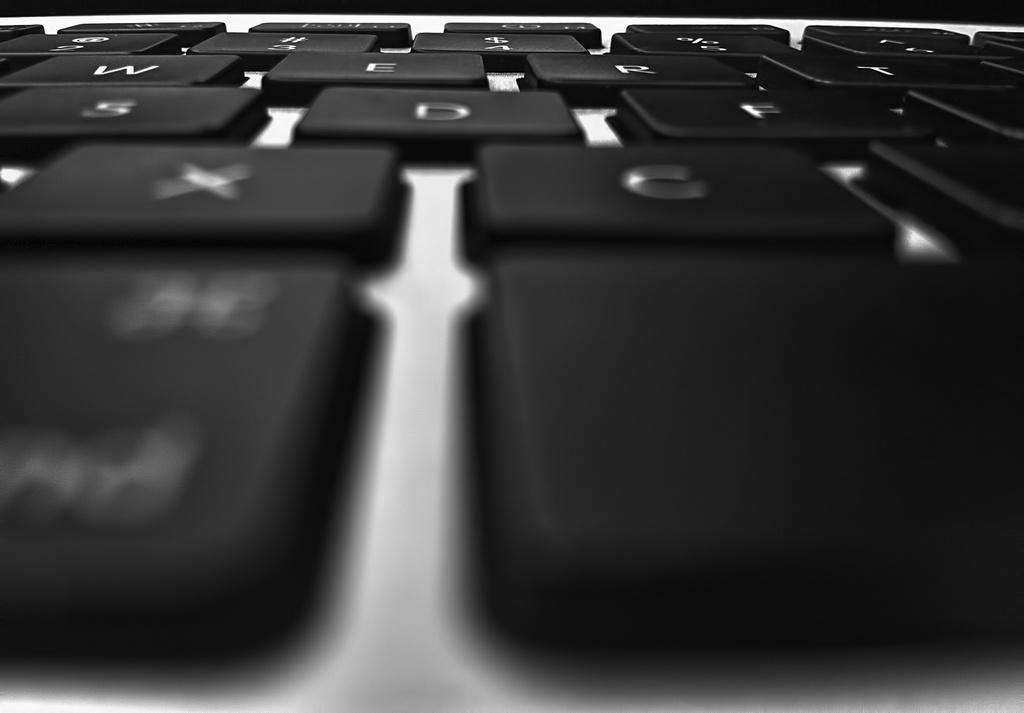Can you describe this image briefly? In this image we can see keys of a keyboard. 